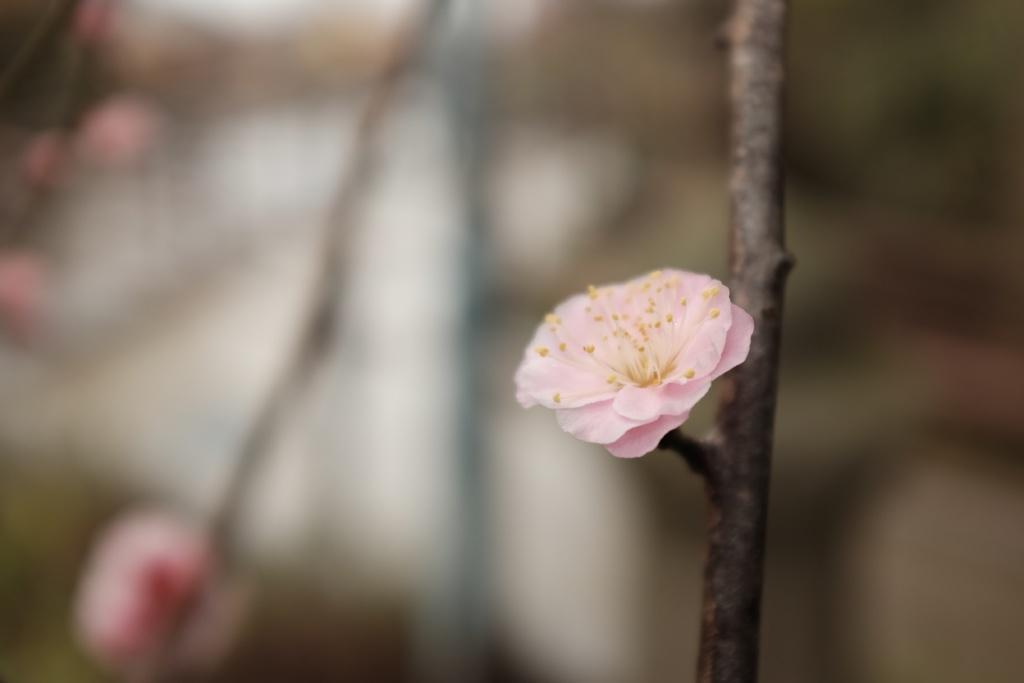Describe this image in one or two sentences. In this image we can see a flower to a stem. The background of the image is blurred. 